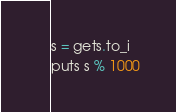<code> <loc_0><loc_0><loc_500><loc_500><_Ruby_>s = gets.to_i
puts s % 1000</code> 